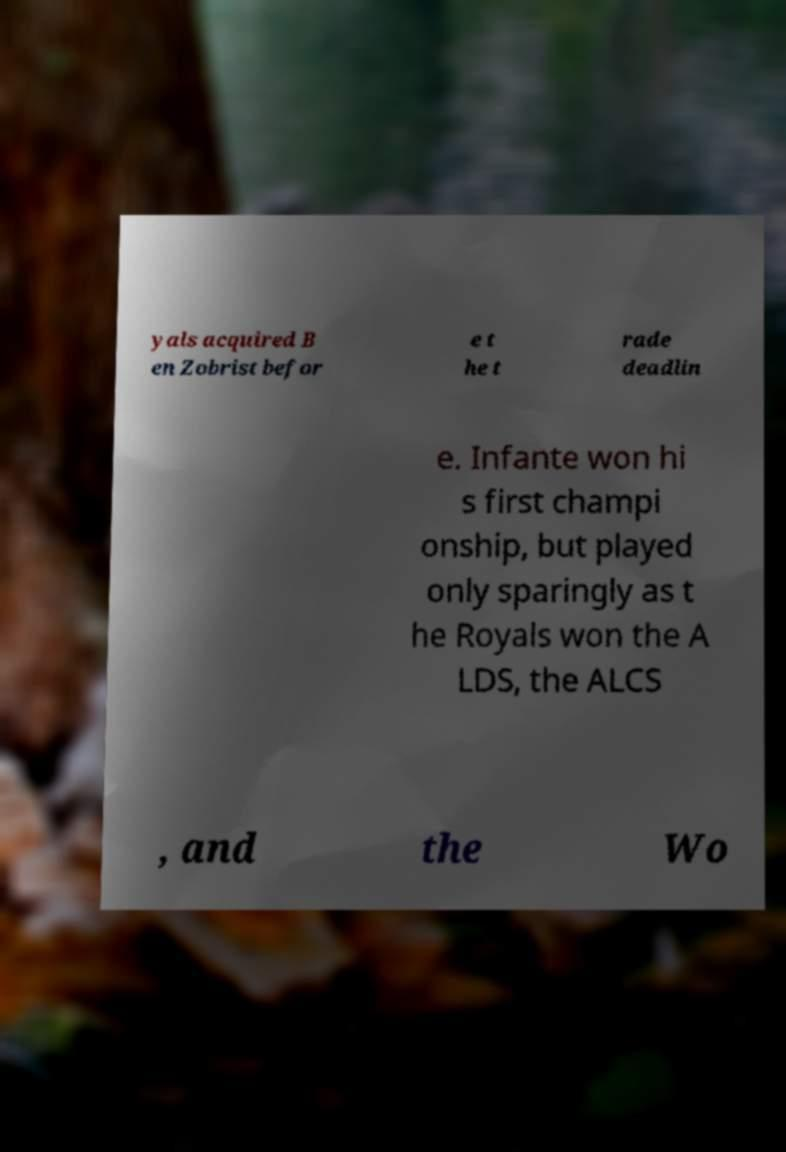Please identify and transcribe the text found in this image. yals acquired B en Zobrist befor e t he t rade deadlin e. Infante won hi s first champi onship, but played only sparingly as t he Royals won the A LDS, the ALCS , and the Wo 